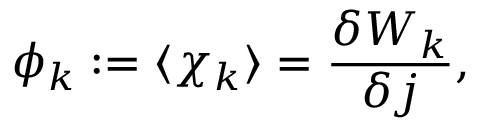Convert formula to latex. <formula><loc_0><loc_0><loc_500><loc_500>\phi _ { k } \colon = \langle \chi _ { k } \rangle = \frac { \delta W _ { k } } { \delta j } ,</formula> 